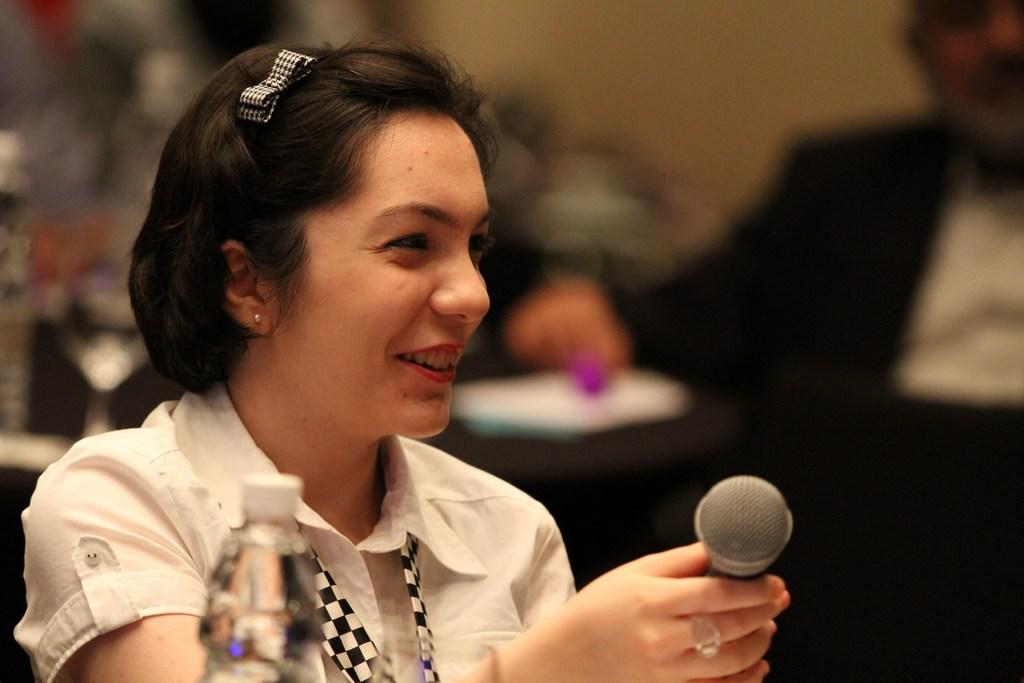Who is present in the image? There is a woman in the image. What is the woman holding? The woman is holding a microphone. What other object can be seen in the image? There is a bottle in the image. What is the man in the image doing? The man is sitting in the image. What type of board is being used by the woman in the image? There is no board present in the image. Can you tell me how much liquid is in the bottle in the image? The image does not provide information about the amount of liquid in the bottle, if any. 